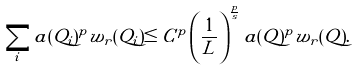<formula> <loc_0><loc_0><loc_500><loc_500>\sum _ { i } a ( Q _ { i } ) ^ { p } w _ { r } ( Q _ { i } ) \leq C ^ { p } \left ( \frac { 1 } { L } \right ) ^ { \frac { p } { s } } a ( Q ) ^ { p } w _ { r } ( Q ) .</formula> 